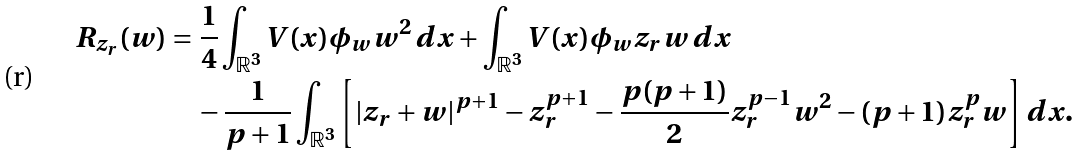Convert formula to latex. <formula><loc_0><loc_0><loc_500><loc_500>R _ { z _ { r } } ( w ) & = \frac { 1 } { 4 } \int _ { \mathbb { R } ^ { 3 } } V ( x ) \phi _ { w } w ^ { 2 } \, d x + \int _ { \mathbb { R } ^ { 3 } } V ( x ) \phi _ { w } z _ { r } w \, d x \\ & \quad - \frac { 1 } { p + 1 } \int _ { \mathbb { R } ^ { 3 } } \left [ | z _ { r } + w | ^ { p + 1 } - z _ { r } ^ { p + 1 } - \frac { p ( p + 1 ) } { 2 } z _ { r } ^ { p - 1 } w ^ { 2 } - ( p + 1 ) z _ { r } ^ { p } w \right ] d x .</formula> 